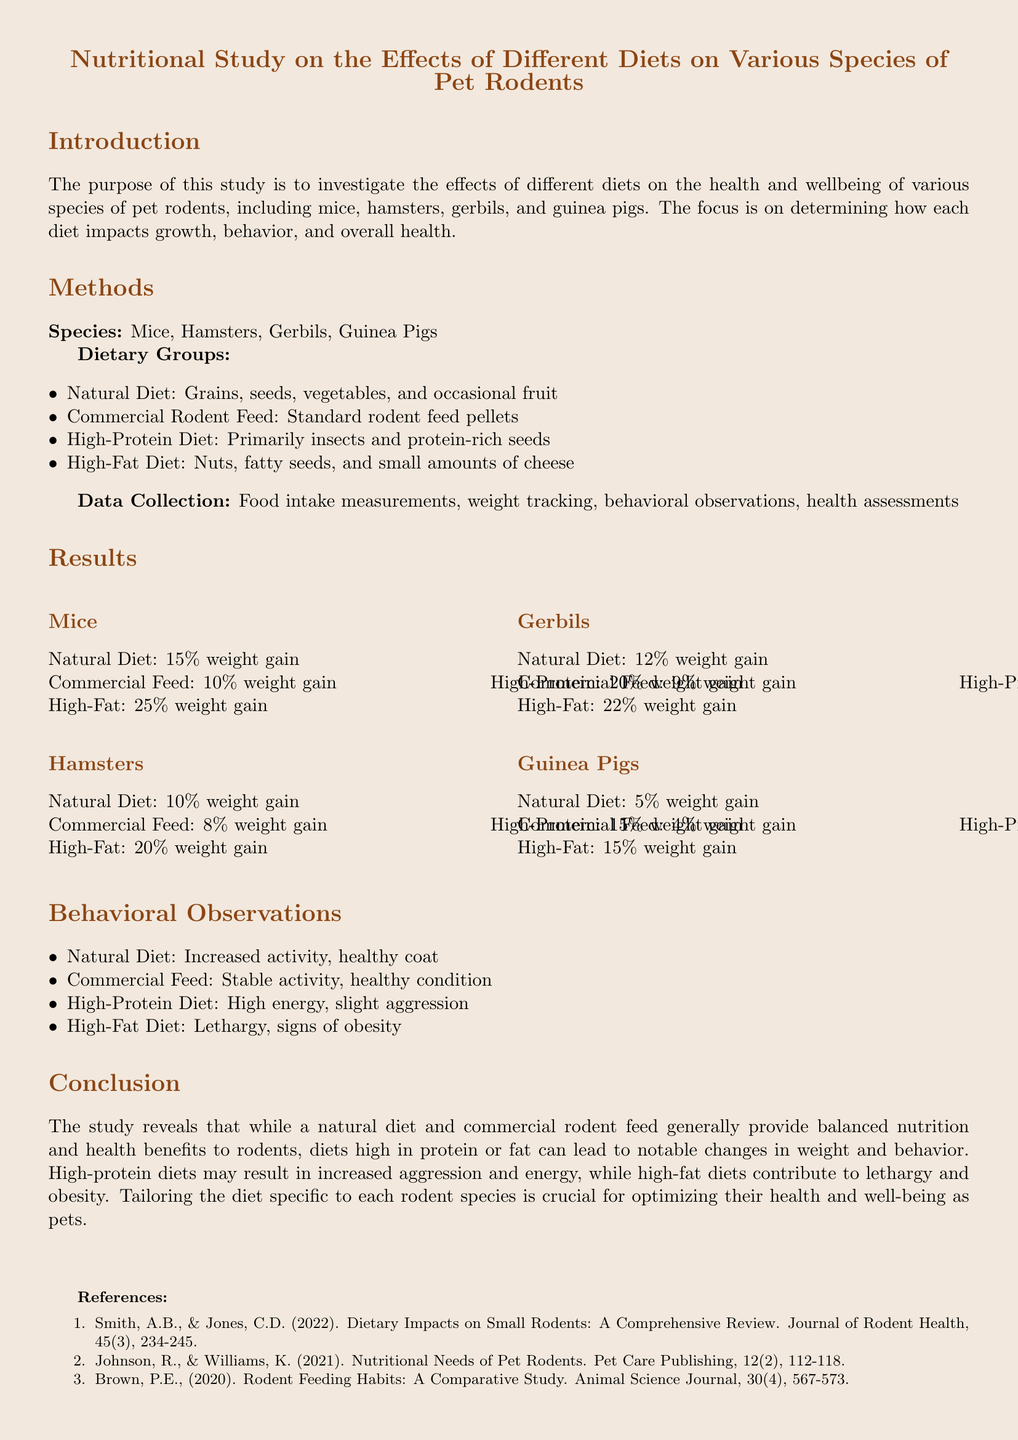What is the purpose of the study? The purpose of the study is to investigate the effects of different diets on the health and wellbeing of various species of pet rodents.
Answer: Investigate effects of diets on health and wellbeing Which dietary group led to the highest weight gain for hamsters? The dietary group leading to the highest weight gain for hamsters, as shown in the results, is the high-fat diet.
Answer: High-Fat Diet What percent weight gain did gerbils experience on a natural diet? The document states that gerbils experienced a 12% weight gain on a natural diet.
Answer: 12% What behavior was observed in rodents on a high-fat diet? The behavior observed in rodents on a high-fat diet includes lethargy and signs of obesity.
Answer: Lethargy, signs of obesity Which rodent species showed the least weight gain in the natural diet category? The species that showed the least weight gain in the natural diet category, according to the results, is guinea pigs.
Answer: Guinea Pigs What is a noted behavioral change for rodents on a high-protein diet? A noted behavioral change for rodents on a high-protein diet is high energy and slight aggression.
Answer: High energy, slight aggression How many species of pet rodents were included in the study? The study included four species of pet rodents.
Answer: Four species What type of document is presented? The document is a lab report that details a nutritional study.
Answer: Lab report Which reference year discusses the nutritional needs of pet rodents? The reference discussing the nutritional needs of pet rodents is from the year 2021.
Answer: 2021 What was the percentage weight gain for guinea pigs on a high-fat diet? The percentage weight gain for guinea pigs on a high-fat diet is 15%.
Answer: 15% 